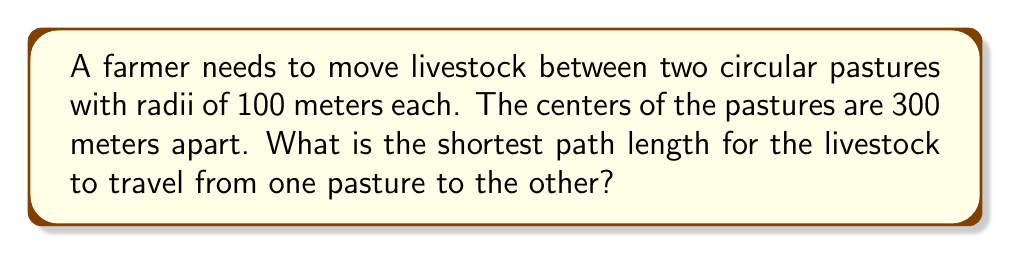Give your solution to this math problem. Let's approach this step-by-step using principles from differential geometry:

1) This problem is equivalent to finding the length of the shortest path between two circles. The shortest path will be a straight line tangent to both circles.

2) Let's visualize the problem:

[asy]
unitsize(0.5mm);
pair A = (0,0), B = (300,0);
draw(circle(A,100));
draw(circle(B,100));
draw(A--B,dashed);
pair P = A + (100,75);
pair Q = B + (-100,75);
draw(P--Q,red);
label("A",A,SW);
label("B",B,SE);
label("P",P,NW);
label("Q",Q,NE);
[/asy]

3) The centers of the circles (A and B) are 300 meters apart. The radii are 100 meters each.

4) The shortest path will be a straight line (PQ in the diagram) tangent to both circles.

5) This forms two right triangles: APC and BQC, where C is the point where PQ intersects AB.

6) In either of these right triangles, we can use the Pythagorean theorem:

   $$AC^2 + PC^2 = AP^2$$

7) We know that AP = 100 (radius), and AC = 300/2 = 150 (half the distance between centers).

8) Substituting:

   $$150^2 + PC^2 = 100^2$$

9) Solving for PC:

   $$PC^2 = 100^2 - 150^2 = 10000 - 22500 = -12500$$
   $$PC = \sqrt{12500} = 50\sqrt{5}$$

10) The length of PQ is twice this value:

    $$PQ = 2 * 50\sqrt{5} = 100\sqrt{5}$$

Therefore, the shortest path length is $100\sqrt{5}$ meters.
Answer: $100\sqrt{5}$ meters 